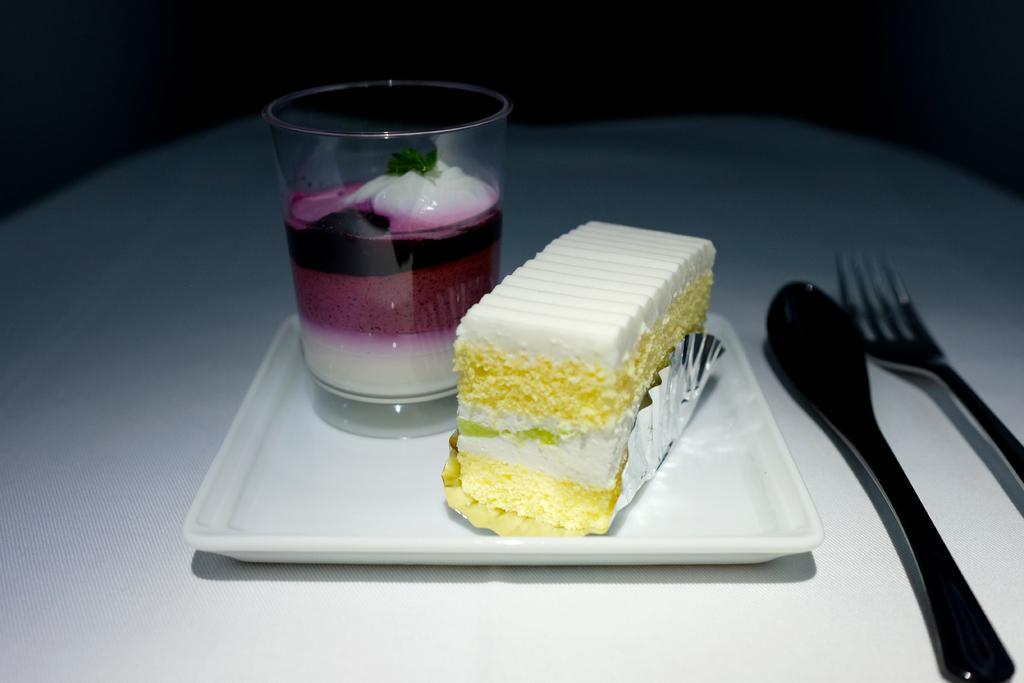Describe this image in one or two sentences. Here, we see a cake with white cream on it and a glass with ice cream filled in it is placed on a plate. Beside the plate, we see spoon and fork spoon which is placed on the dining table covered with white color cloth. 